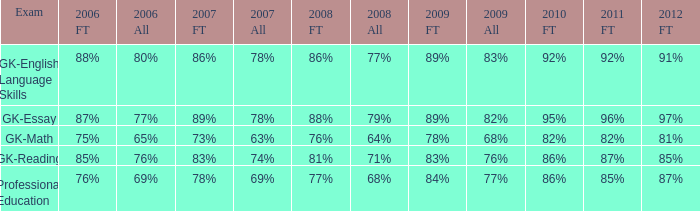What is the percentage for first time in 2012 when it was 82% for all in 2009? 97%. 